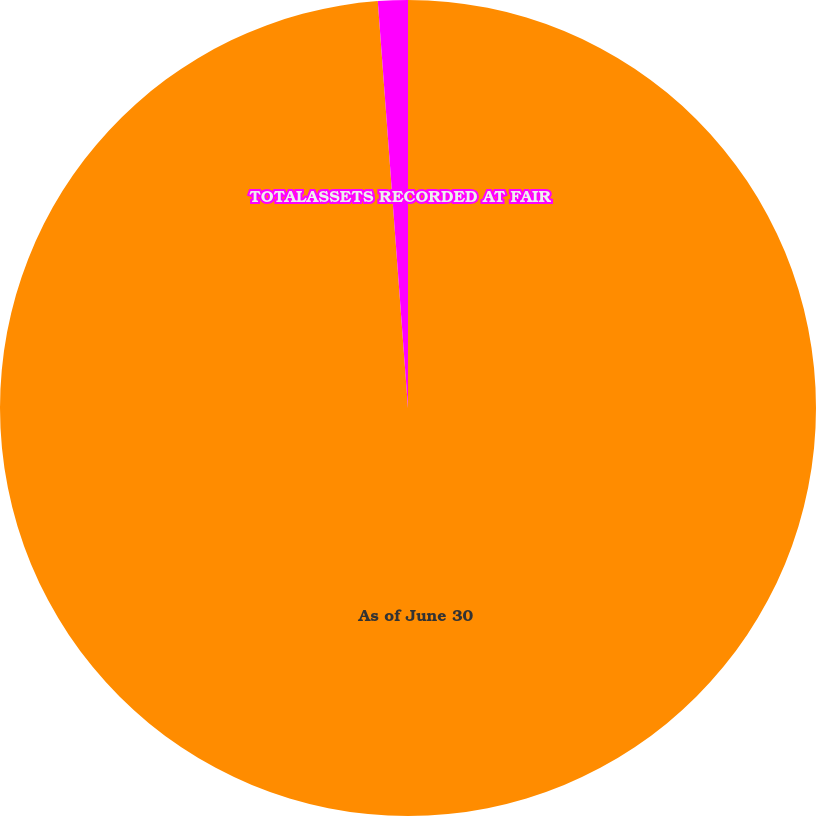Convert chart to OTSL. <chart><loc_0><loc_0><loc_500><loc_500><pie_chart><fcel>As of June 30<fcel>TOTALASSETS RECORDED AT FAIR<nl><fcel>98.82%<fcel>1.18%<nl></chart> 